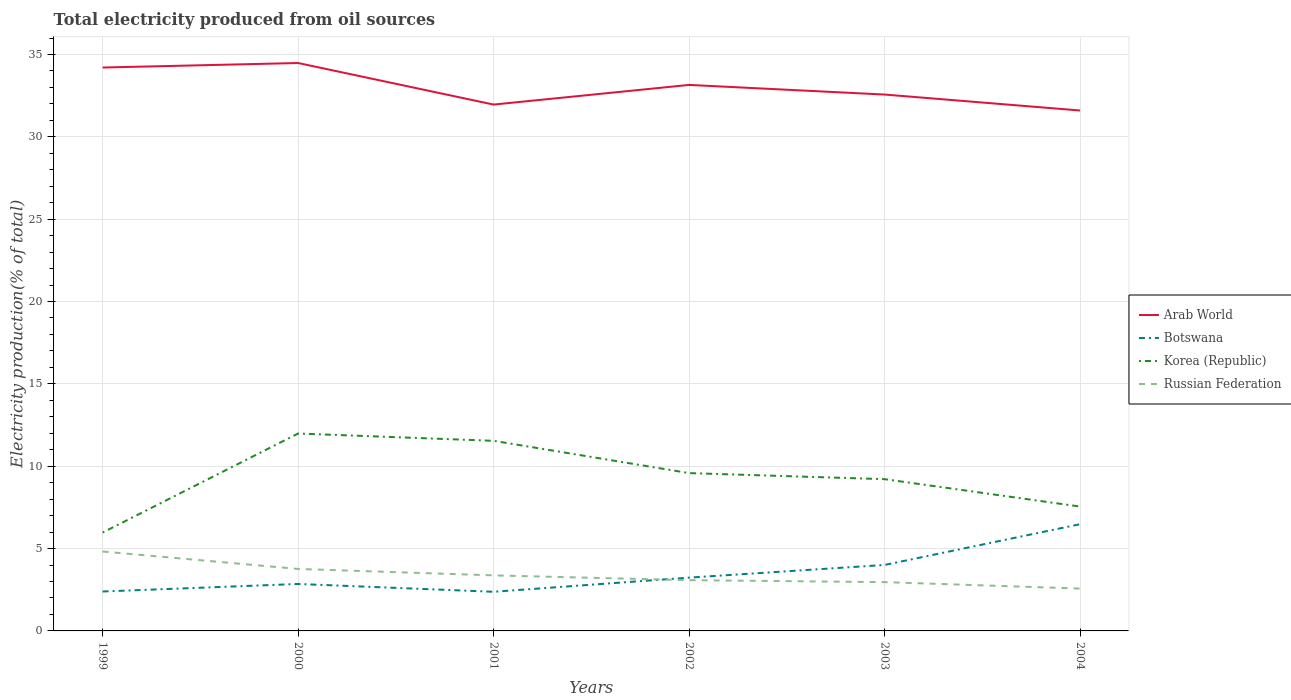Across all years, what is the maximum total electricity produced in Arab World?
Give a very brief answer. 31.6. What is the total total electricity produced in Botswana in the graph?
Provide a short and direct response. -4.1. What is the difference between the highest and the second highest total electricity produced in Botswana?
Your response must be concise. 4.1. What is the difference between two consecutive major ticks on the Y-axis?
Ensure brevity in your answer.  5. Does the graph contain any zero values?
Your answer should be very brief. No. Does the graph contain grids?
Your response must be concise. Yes. How many legend labels are there?
Give a very brief answer. 4. What is the title of the graph?
Your response must be concise. Total electricity produced from oil sources. Does "Spain" appear as one of the legend labels in the graph?
Provide a succinct answer. No. What is the label or title of the X-axis?
Offer a very short reply. Years. What is the label or title of the Y-axis?
Ensure brevity in your answer.  Electricity production(% of total). What is the Electricity production(% of total) of Arab World in 1999?
Provide a short and direct response. 34.21. What is the Electricity production(% of total) in Botswana in 1999?
Provide a short and direct response. 2.39. What is the Electricity production(% of total) in Korea (Republic) in 1999?
Provide a succinct answer. 5.97. What is the Electricity production(% of total) in Russian Federation in 1999?
Provide a short and direct response. 4.82. What is the Electricity production(% of total) of Arab World in 2000?
Your answer should be compact. 34.48. What is the Electricity production(% of total) in Botswana in 2000?
Your answer should be very brief. 2.85. What is the Electricity production(% of total) of Korea (Republic) in 2000?
Your response must be concise. 11.99. What is the Electricity production(% of total) in Russian Federation in 2000?
Give a very brief answer. 3.76. What is the Electricity production(% of total) in Arab World in 2001?
Provide a succinct answer. 31.96. What is the Electricity production(% of total) in Botswana in 2001?
Make the answer very short. 2.38. What is the Electricity production(% of total) in Korea (Republic) in 2001?
Your response must be concise. 11.54. What is the Electricity production(% of total) of Russian Federation in 2001?
Offer a very short reply. 3.37. What is the Electricity production(% of total) of Arab World in 2002?
Your answer should be very brief. 33.15. What is the Electricity production(% of total) of Botswana in 2002?
Your answer should be very brief. 3.24. What is the Electricity production(% of total) of Korea (Republic) in 2002?
Ensure brevity in your answer.  9.58. What is the Electricity production(% of total) of Russian Federation in 2002?
Your answer should be very brief. 3.08. What is the Electricity production(% of total) in Arab World in 2003?
Offer a terse response. 32.57. What is the Electricity production(% of total) in Botswana in 2003?
Make the answer very short. 4.01. What is the Electricity production(% of total) in Korea (Republic) in 2003?
Give a very brief answer. 9.21. What is the Electricity production(% of total) of Russian Federation in 2003?
Your answer should be very brief. 2.96. What is the Electricity production(% of total) in Arab World in 2004?
Make the answer very short. 31.6. What is the Electricity production(% of total) of Botswana in 2004?
Keep it short and to the point. 6.48. What is the Electricity production(% of total) in Korea (Republic) in 2004?
Provide a succinct answer. 7.55. What is the Electricity production(% of total) in Russian Federation in 2004?
Offer a terse response. 2.57. Across all years, what is the maximum Electricity production(% of total) in Arab World?
Make the answer very short. 34.48. Across all years, what is the maximum Electricity production(% of total) in Botswana?
Make the answer very short. 6.48. Across all years, what is the maximum Electricity production(% of total) of Korea (Republic)?
Your answer should be very brief. 11.99. Across all years, what is the maximum Electricity production(% of total) of Russian Federation?
Ensure brevity in your answer.  4.82. Across all years, what is the minimum Electricity production(% of total) of Arab World?
Offer a very short reply. 31.6. Across all years, what is the minimum Electricity production(% of total) in Botswana?
Your response must be concise. 2.38. Across all years, what is the minimum Electricity production(% of total) in Korea (Republic)?
Provide a succinct answer. 5.97. Across all years, what is the minimum Electricity production(% of total) in Russian Federation?
Give a very brief answer. 2.57. What is the total Electricity production(% of total) of Arab World in the graph?
Offer a terse response. 197.97. What is the total Electricity production(% of total) in Botswana in the graph?
Your answer should be compact. 21.34. What is the total Electricity production(% of total) of Korea (Republic) in the graph?
Provide a short and direct response. 55.85. What is the total Electricity production(% of total) in Russian Federation in the graph?
Ensure brevity in your answer.  20.57. What is the difference between the Electricity production(% of total) in Arab World in 1999 and that in 2000?
Ensure brevity in your answer.  -0.27. What is the difference between the Electricity production(% of total) in Botswana in 1999 and that in 2000?
Your answer should be very brief. -0.46. What is the difference between the Electricity production(% of total) of Korea (Republic) in 1999 and that in 2000?
Your answer should be compact. -6.01. What is the difference between the Electricity production(% of total) of Russian Federation in 1999 and that in 2000?
Make the answer very short. 1.06. What is the difference between the Electricity production(% of total) of Arab World in 1999 and that in 2001?
Give a very brief answer. 2.25. What is the difference between the Electricity production(% of total) of Botswana in 1999 and that in 2001?
Give a very brief answer. 0.02. What is the difference between the Electricity production(% of total) in Korea (Republic) in 1999 and that in 2001?
Make the answer very short. -5.57. What is the difference between the Electricity production(% of total) in Russian Federation in 1999 and that in 2001?
Keep it short and to the point. 1.45. What is the difference between the Electricity production(% of total) of Arab World in 1999 and that in 2002?
Ensure brevity in your answer.  1.06. What is the difference between the Electricity production(% of total) of Botswana in 1999 and that in 2002?
Offer a very short reply. -0.84. What is the difference between the Electricity production(% of total) of Korea (Republic) in 1999 and that in 2002?
Ensure brevity in your answer.  -3.61. What is the difference between the Electricity production(% of total) in Russian Federation in 1999 and that in 2002?
Make the answer very short. 1.74. What is the difference between the Electricity production(% of total) of Arab World in 1999 and that in 2003?
Provide a succinct answer. 1.64. What is the difference between the Electricity production(% of total) of Botswana in 1999 and that in 2003?
Provide a short and direct response. -1.61. What is the difference between the Electricity production(% of total) of Korea (Republic) in 1999 and that in 2003?
Offer a very short reply. -3.24. What is the difference between the Electricity production(% of total) of Russian Federation in 1999 and that in 2003?
Your answer should be compact. 1.86. What is the difference between the Electricity production(% of total) of Arab World in 1999 and that in 2004?
Offer a terse response. 2.61. What is the difference between the Electricity production(% of total) of Botswana in 1999 and that in 2004?
Offer a terse response. -4.09. What is the difference between the Electricity production(% of total) in Korea (Republic) in 1999 and that in 2004?
Your answer should be very brief. -1.58. What is the difference between the Electricity production(% of total) in Russian Federation in 1999 and that in 2004?
Ensure brevity in your answer.  2.25. What is the difference between the Electricity production(% of total) of Arab World in 2000 and that in 2001?
Make the answer very short. 2.52. What is the difference between the Electricity production(% of total) of Botswana in 2000 and that in 2001?
Your answer should be very brief. 0.47. What is the difference between the Electricity production(% of total) of Korea (Republic) in 2000 and that in 2001?
Provide a succinct answer. 0.44. What is the difference between the Electricity production(% of total) of Russian Federation in 2000 and that in 2001?
Offer a very short reply. 0.39. What is the difference between the Electricity production(% of total) of Arab World in 2000 and that in 2002?
Give a very brief answer. 1.33. What is the difference between the Electricity production(% of total) of Botswana in 2000 and that in 2002?
Ensure brevity in your answer.  -0.39. What is the difference between the Electricity production(% of total) in Korea (Republic) in 2000 and that in 2002?
Provide a short and direct response. 2.4. What is the difference between the Electricity production(% of total) of Russian Federation in 2000 and that in 2002?
Keep it short and to the point. 0.68. What is the difference between the Electricity production(% of total) of Arab World in 2000 and that in 2003?
Ensure brevity in your answer.  1.91. What is the difference between the Electricity production(% of total) of Botswana in 2000 and that in 2003?
Offer a very short reply. -1.15. What is the difference between the Electricity production(% of total) in Korea (Republic) in 2000 and that in 2003?
Give a very brief answer. 2.77. What is the difference between the Electricity production(% of total) in Russian Federation in 2000 and that in 2003?
Provide a short and direct response. 0.8. What is the difference between the Electricity production(% of total) in Arab World in 2000 and that in 2004?
Ensure brevity in your answer.  2.88. What is the difference between the Electricity production(% of total) of Botswana in 2000 and that in 2004?
Offer a terse response. -3.63. What is the difference between the Electricity production(% of total) in Korea (Republic) in 2000 and that in 2004?
Give a very brief answer. 4.44. What is the difference between the Electricity production(% of total) in Russian Federation in 2000 and that in 2004?
Make the answer very short. 1.19. What is the difference between the Electricity production(% of total) in Arab World in 2001 and that in 2002?
Give a very brief answer. -1.19. What is the difference between the Electricity production(% of total) in Botswana in 2001 and that in 2002?
Provide a succinct answer. -0.86. What is the difference between the Electricity production(% of total) of Korea (Republic) in 2001 and that in 2002?
Keep it short and to the point. 1.96. What is the difference between the Electricity production(% of total) in Russian Federation in 2001 and that in 2002?
Offer a very short reply. 0.29. What is the difference between the Electricity production(% of total) of Arab World in 2001 and that in 2003?
Make the answer very short. -0.61. What is the difference between the Electricity production(% of total) in Botswana in 2001 and that in 2003?
Keep it short and to the point. -1.63. What is the difference between the Electricity production(% of total) of Korea (Republic) in 2001 and that in 2003?
Your answer should be compact. 2.33. What is the difference between the Electricity production(% of total) of Russian Federation in 2001 and that in 2003?
Offer a very short reply. 0.41. What is the difference between the Electricity production(% of total) of Arab World in 2001 and that in 2004?
Your answer should be very brief. 0.36. What is the difference between the Electricity production(% of total) of Botswana in 2001 and that in 2004?
Ensure brevity in your answer.  -4.1. What is the difference between the Electricity production(% of total) in Korea (Republic) in 2001 and that in 2004?
Give a very brief answer. 3.99. What is the difference between the Electricity production(% of total) in Russian Federation in 2001 and that in 2004?
Offer a very short reply. 0.8. What is the difference between the Electricity production(% of total) in Arab World in 2002 and that in 2003?
Give a very brief answer. 0.58. What is the difference between the Electricity production(% of total) of Botswana in 2002 and that in 2003?
Your response must be concise. -0.77. What is the difference between the Electricity production(% of total) in Korea (Republic) in 2002 and that in 2003?
Give a very brief answer. 0.37. What is the difference between the Electricity production(% of total) in Russian Federation in 2002 and that in 2003?
Offer a very short reply. 0.12. What is the difference between the Electricity production(% of total) of Arab World in 2002 and that in 2004?
Your answer should be very brief. 1.55. What is the difference between the Electricity production(% of total) of Botswana in 2002 and that in 2004?
Provide a short and direct response. -3.24. What is the difference between the Electricity production(% of total) of Korea (Republic) in 2002 and that in 2004?
Make the answer very short. 2.03. What is the difference between the Electricity production(% of total) of Russian Federation in 2002 and that in 2004?
Provide a short and direct response. 0.51. What is the difference between the Electricity production(% of total) in Arab World in 2003 and that in 2004?
Give a very brief answer. 0.97. What is the difference between the Electricity production(% of total) in Botswana in 2003 and that in 2004?
Provide a succinct answer. -2.47. What is the difference between the Electricity production(% of total) of Korea (Republic) in 2003 and that in 2004?
Your answer should be very brief. 1.66. What is the difference between the Electricity production(% of total) in Russian Federation in 2003 and that in 2004?
Provide a short and direct response. 0.39. What is the difference between the Electricity production(% of total) in Arab World in 1999 and the Electricity production(% of total) in Botswana in 2000?
Your answer should be very brief. 31.36. What is the difference between the Electricity production(% of total) of Arab World in 1999 and the Electricity production(% of total) of Korea (Republic) in 2000?
Ensure brevity in your answer.  22.22. What is the difference between the Electricity production(% of total) in Arab World in 1999 and the Electricity production(% of total) in Russian Federation in 2000?
Give a very brief answer. 30.44. What is the difference between the Electricity production(% of total) in Botswana in 1999 and the Electricity production(% of total) in Korea (Republic) in 2000?
Make the answer very short. -9.59. What is the difference between the Electricity production(% of total) of Botswana in 1999 and the Electricity production(% of total) of Russian Federation in 2000?
Ensure brevity in your answer.  -1.37. What is the difference between the Electricity production(% of total) of Korea (Republic) in 1999 and the Electricity production(% of total) of Russian Federation in 2000?
Ensure brevity in your answer.  2.21. What is the difference between the Electricity production(% of total) in Arab World in 1999 and the Electricity production(% of total) in Botswana in 2001?
Provide a succinct answer. 31.83. What is the difference between the Electricity production(% of total) of Arab World in 1999 and the Electricity production(% of total) of Korea (Republic) in 2001?
Provide a succinct answer. 22.67. What is the difference between the Electricity production(% of total) of Arab World in 1999 and the Electricity production(% of total) of Russian Federation in 2001?
Provide a succinct answer. 30.84. What is the difference between the Electricity production(% of total) in Botswana in 1999 and the Electricity production(% of total) in Korea (Republic) in 2001?
Ensure brevity in your answer.  -9.15. What is the difference between the Electricity production(% of total) of Botswana in 1999 and the Electricity production(% of total) of Russian Federation in 2001?
Your answer should be very brief. -0.98. What is the difference between the Electricity production(% of total) of Korea (Republic) in 1999 and the Electricity production(% of total) of Russian Federation in 2001?
Provide a short and direct response. 2.6. What is the difference between the Electricity production(% of total) of Arab World in 1999 and the Electricity production(% of total) of Botswana in 2002?
Make the answer very short. 30.97. What is the difference between the Electricity production(% of total) of Arab World in 1999 and the Electricity production(% of total) of Korea (Republic) in 2002?
Keep it short and to the point. 24.63. What is the difference between the Electricity production(% of total) in Arab World in 1999 and the Electricity production(% of total) in Russian Federation in 2002?
Ensure brevity in your answer.  31.13. What is the difference between the Electricity production(% of total) in Botswana in 1999 and the Electricity production(% of total) in Korea (Republic) in 2002?
Give a very brief answer. -7.19. What is the difference between the Electricity production(% of total) in Botswana in 1999 and the Electricity production(% of total) in Russian Federation in 2002?
Your response must be concise. -0.69. What is the difference between the Electricity production(% of total) in Korea (Republic) in 1999 and the Electricity production(% of total) in Russian Federation in 2002?
Keep it short and to the point. 2.89. What is the difference between the Electricity production(% of total) in Arab World in 1999 and the Electricity production(% of total) in Botswana in 2003?
Your answer should be compact. 30.2. What is the difference between the Electricity production(% of total) in Arab World in 1999 and the Electricity production(% of total) in Korea (Republic) in 2003?
Offer a very short reply. 24.99. What is the difference between the Electricity production(% of total) in Arab World in 1999 and the Electricity production(% of total) in Russian Federation in 2003?
Your response must be concise. 31.24. What is the difference between the Electricity production(% of total) of Botswana in 1999 and the Electricity production(% of total) of Korea (Republic) in 2003?
Your answer should be very brief. -6.82. What is the difference between the Electricity production(% of total) of Botswana in 1999 and the Electricity production(% of total) of Russian Federation in 2003?
Keep it short and to the point. -0.57. What is the difference between the Electricity production(% of total) in Korea (Republic) in 1999 and the Electricity production(% of total) in Russian Federation in 2003?
Your answer should be compact. 3.01. What is the difference between the Electricity production(% of total) in Arab World in 1999 and the Electricity production(% of total) in Botswana in 2004?
Your response must be concise. 27.73. What is the difference between the Electricity production(% of total) in Arab World in 1999 and the Electricity production(% of total) in Korea (Republic) in 2004?
Your response must be concise. 26.66. What is the difference between the Electricity production(% of total) in Arab World in 1999 and the Electricity production(% of total) in Russian Federation in 2004?
Provide a short and direct response. 31.64. What is the difference between the Electricity production(% of total) in Botswana in 1999 and the Electricity production(% of total) in Korea (Republic) in 2004?
Your answer should be compact. -5.16. What is the difference between the Electricity production(% of total) in Botswana in 1999 and the Electricity production(% of total) in Russian Federation in 2004?
Ensure brevity in your answer.  -0.18. What is the difference between the Electricity production(% of total) in Korea (Republic) in 1999 and the Electricity production(% of total) in Russian Federation in 2004?
Provide a succinct answer. 3.4. What is the difference between the Electricity production(% of total) of Arab World in 2000 and the Electricity production(% of total) of Botswana in 2001?
Ensure brevity in your answer.  32.11. What is the difference between the Electricity production(% of total) in Arab World in 2000 and the Electricity production(% of total) in Korea (Republic) in 2001?
Keep it short and to the point. 22.94. What is the difference between the Electricity production(% of total) of Arab World in 2000 and the Electricity production(% of total) of Russian Federation in 2001?
Offer a very short reply. 31.11. What is the difference between the Electricity production(% of total) of Botswana in 2000 and the Electricity production(% of total) of Korea (Republic) in 2001?
Keep it short and to the point. -8.69. What is the difference between the Electricity production(% of total) of Botswana in 2000 and the Electricity production(% of total) of Russian Federation in 2001?
Your answer should be very brief. -0.52. What is the difference between the Electricity production(% of total) in Korea (Republic) in 2000 and the Electricity production(% of total) in Russian Federation in 2001?
Your response must be concise. 8.61. What is the difference between the Electricity production(% of total) of Arab World in 2000 and the Electricity production(% of total) of Botswana in 2002?
Keep it short and to the point. 31.25. What is the difference between the Electricity production(% of total) of Arab World in 2000 and the Electricity production(% of total) of Korea (Republic) in 2002?
Your answer should be compact. 24.9. What is the difference between the Electricity production(% of total) in Arab World in 2000 and the Electricity production(% of total) in Russian Federation in 2002?
Offer a very short reply. 31.4. What is the difference between the Electricity production(% of total) in Botswana in 2000 and the Electricity production(% of total) in Korea (Republic) in 2002?
Provide a short and direct response. -6.73. What is the difference between the Electricity production(% of total) in Botswana in 2000 and the Electricity production(% of total) in Russian Federation in 2002?
Your answer should be very brief. -0.23. What is the difference between the Electricity production(% of total) in Korea (Republic) in 2000 and the Electricity production(% of total) in Russian Federation in 2002?
Your answer should be compact. 8.9. What is the difference between the Electricity production(% of total) in Arab World in 2000 and the Electricity production(% of total) in Botswana in 2003?
Keep it short and to the point. 30.48. What is the difference between the Electricity production(% of total) of Arab World in 2000 and the Electricity production(% of total) of Korea (Republic) in 2003?
Your answer should be very brief. 25.27. What is the difference between the Electricity production(% of total) of Arab World in 2000 and the Electricity production(% of total) of Russian Federation in 2003?
Offer a very short reply. 31.52. What is the difference between the Electricity production(% of total) in Botswana in 2000 and the Electricity production(% of total) in Korea (Republic) in 2003?
Ensure brevity in your answer.  -6.36. What is the difference between the Electricity production(% of total) in Botswana in 2000 and the Electricity production(% of total) in Russian Federation in 2003?
Offer a terse response. -0.11. What is the difference between the Electricity production(% of total) of Korea (Republic) in 2000 and the Electricity production(% of total) of Russian Federation in 2003?
Provide a succinct answer. 9.02. What is the difference between the Electricity production(% of total) of Arab World in 2000 and the Electricity production(% of total) of Botswana in 2004?
Your response must be concise. 28. What is the difference between the Electricity production(% of total) in Arab World in 2000 and the Electricity production(% of total) in Korea (Republic) in 2004?
Your response must be concise. 26.93. What is the difference between the Electricity production(% of total) of Arab World in 2000 and the Electricity production(% of total) of Russian Federation in 2004?
Keep it short and to the point. 31.91. What is the difference between the Electricity production(% of total) of Botswana in 2000 and the Electricity production(% of total) of Korea (Republic) in 2004?
Keep it short and to the point. -4.7. What is the difference between the Electricity production(% of total) of Botswana in 2000 and the Electricity production(% of total) of Russian Federation in 2004?
Make the answer very short. 0.28. What is the difference between the Electricity production(% of total) in Korea (Republic) in 2000 and the Electricity production(% of total) in Russian Federation in 2004?
Provide a succinct answer. 9.41. What is the difference between the Electricity production(% of total) in Arab World in 2001 and the Electricity production(% of total) in Botswana in 2002?
Provide a short and direct response. 28.72. What is the difference between the Electricity production(% of total) of Arab World in 2001 and the Electricity production(% of total) of Korea (Republic) in 2002?
Ensure brevity in your answer.  22.38. What is the difference between the Electricity production(% of total) of Arab World in 2001 and the Electricity production(% of total) of Russian Federation in 2002?
Your answer should be very brief. 28.88. What is the difference between the Electricity production(% of total) in Botswana in 2001 and the Electricity production(% of total) in Korea (Republic) in 2002?
Offer a very short reply. -7.21. What is the difference between the Electricity production(% of total) in Botswana in 2001 and the Electricity production(% of total) in Russian Federation in 2002?
Ensure brevity in your answer.  -0.71. What is the difference between the Electricity production(% of total) of Korea (Republic) in 2001 and the Electricity production(% of total) of Russian Federation in 2002?
Provide a succinct answer. 8.46. What is the difference between the Electricity production(% of total) in Arab World in 2001 and the Electricity production(% of total) in Botswana in 2003?
Make the answer very short. 27.95. What is the difference between the Electricity production(% of total) in Arab World in 2001 and the Electricity production(% of total) in Korea (Republic) in 2003?
Provide a succinct answer. 22.74. What is the difference between the Electricity production(% of total) of Arab World in 2001 and the Electricity production(% of total) of Russian Federation in 2003?
Give a very brief answer. 29. What is the difference between the Electricity production(% of total) of Botswana in 2001 and the Electricity production(% of total) of Korea (Republic) in 2003?
Provide a succinct answer. -6.84. What is the difference between the Electricity production(% of total) in Botswana in 2001 and the Electricity production(% of total) in Russian Federation in 2003?
Your answer should be very brief. -0.59. What is the difference between the Electricity production(% of total) of Korea (Republic) in 2001 and the Electricity production(% of total) of Russian Federation in 2003?
Your answer should be compact. 8.58. What is the difference between the Electricity production(% of total) of Arab World in 2001 and the Electricity production(% of total) of Botswana in 2004?
Give a very brief answer. 25.48. What is the difference between the Electricity production(% of total) of Arab World in 2001 and the Electricity production(% of total) of Korea (Republic) in 2004?
Keep it short and to the point. 24.41. What is the difference between the Electricity production(% of total) of Arab World in 2001 and the Electricity production(% of total) of Russian Federation in 2004?
Make the answer very short. 29.39. What is the difference between the Electricity production(% of total) in Botswana in 2001 and the Electricity production(% of total) in Korea (Republic) in 2004?
Provide a succinct answer. -5.17. What is the difference between the Electricity production(% of total) in Botswana in 2001 and the Electricity production(% of total) in Russian Federation in 2004?
Keep it short and to the point. -0.19. What is the difference between the Electricity production(% of total) of Korea (Republic) in 2001 and the Electricity production(% of total) of Russian Federation in 2004?
Ensure brevity in your answer.  8.97. What is the difference between the Electricity production(% of total) of Arab World in 2002 and the Electricity production(% of total) of Botswana in 2003?
Offer a very short reply. 29.15. What is the difference between the Electricity production(% of total) of Arab World in 2002 and the Electricity production(% of total) of Korea (Republic) in 2003?
Keep it short and to the point. 23.94. What is the difference between the Electricity production(% of total) of Arab World in 2002 and the Electricity production(% of total) of Russian Federation in 2003?
Offer a very short reply. 30.19. What is the difference between the Electricity production(% of total) in Botswana in 2002 and the Electricity production(% of total) in Korea (Republic) in 2003?
Ensure brevity in your answer.  -5.98. What is the difference between the Electricity production(% of total) of Botswana in 2002 and the Electricity production(% of total) of Russian Federation in 2003?
Provide a succinct answer. 0.27. What is the difference between the Electricity production(% of total) of Korea (Republic) in 2002 and the Electricity production(% of total) of Russian Federation in 2003?
Offer a terse response. 6.62. What is the difference between the Electricity production(% of total) of Arab World in 2002 and the Electricity production(% of total) of Botswana in 2004?
Your response must be concise. 26.67. What is the difference between the Electricity production(% of total) in Arab World in 2002 and the Electricity production(% of total) in Korea (Republic) in 2004?
Make the answer very short. 25.6. What is the difference between the Electricity production(% of total) in Arab World in 2002 and the Electricity production(% of total) in Russian Federation in 2004?
Your response must be concise. 30.58. What is the difference between the Electricity production(% of total) in Botswana in 2002 and the Electricity production(% of total) in Korea (Republic) in 2004?
Make the answer very short. -4.31. What is the difference between the Electricity production(% of total) of Botswana in 2002 and the Electricity production(% of total) of Russian Federation in 2004?
Offer a terse response. 0.67. What is the difference between the Electricity production(% of total) in Korea (Republic) in 2002 and the Electricity production(% of total) in Russian Federation in 2004?
Ensure brevity in your answer.  7.01. What is the difference between the Electricity production(% of total) in Arab World in 2003 and the Electricity production(% of total) in Botswana in 2004?
Give a very brief answer. 26.09. What is the difference between the Electricity production(% of total) in Arab World in 2003 and the Electricity production(% of total) in Korea (Republic) in 2004?
Your response must be concise. 25.02. What is the difference between the Electricity production(% of total) of Arab World in 2003 and the Electricity production(% of total) of Russian Federation in 2004?
Your answer should be very brief. 30. What is the difference between the Electricity production(% of total) of Botswana in 2003 and the Electricity production(% of total) of Korea (Republic) in 2004?
Your answer should be very brief. -3.54. What is the difference between the Electricity production(% of total) of Botswana in 2003 and the Electricity production(% of total) of Russian Federation in 2004?
Your answer should be compact. 1.43. What is the difference between the Electricity production(% of total) of Korea (Republic) in 2003 and the Electricity production(% of total) of Russian Federation in 2004?
Your answer should be very brief. 6.64. What is the average Electricity production(% of total) of Arab World per year?
Keep it short and to the point. 32.99. What is the average Electricity production(% of total) in Botswana per year?
Give a very brief answer. 3.56. What is the average Electricity production(% of total) in Korea (Republic) per year?
Provide a short and direct response. 9.31. What is the average Electricity production(% of total) of Russian Federation per year?
Give a very brief answer. 3.43. In the year 1999, what is the difference between the Electricity production(% of total) in Arab World and Electricity production(% of total) in Botswana?
Offer a terse response. 31.81. In the year 1999, what is the difference between the Electricity production(% of total) in Arab World and Electricity production(% of total) in Korea (Republic)?
Offer a terse response. 28.24. In the year 1999, what is the difference between the Electricity production(% of total) of Arab World and Electricity production(% of total) of Russian Federation?
Provide a succinct answer. 29.39. In the year 1999, what is the difference between the Electricity production(% of total) of Botswana and Electricity production(% of total) of Korea (Republic)?
Your answer should be compact. -3.58. In the year 1999, what is the difference between the Electricity production(% of total) of Botswana and Electricity production(% of total) of Russian Federation?
Provide a short and direct response. -2.43. In the year 1999, what is the difference between the Electricity production(% of total) in Korea (Republic) and Electricity production(% of total) in Russian Federation?
Make the answer very short. 1.15. In the year 2000, what is the difference between the Electricity production(% of total) of Arab World and Electricity production(% of total) of Botswana?
Provide a succinct answer. 31.63. In the year 2000, what is the difference between the Electricity production(% of total) in Arab World and Electricity production(% of total) in Korea (Republic)?
Provide a short and direct response. 22.5. In the year 2000, what is the difference between the Electricity production(% of total) of Arab World and Electricity production(% of total) of Russian Federation?
Your response must be concise. 30.72. In the year 2000, what is the difference between the Electricity production(% of total) of Botswana and Electricity production(% of total) of Korea (Republic)?
Your response must be concise. -9.13. In the year 2000, what is the difference between the Electricity production(% of total) in Botswana and Electricity production(% of total) in Russian Federation?
Provide a short and direct response. -0.91. In the year 2000, what is the difference between the Electricity production(% of total) in Korea (Republic) and Electricity production(% of total) in Russian Federation?
Provide a short and direct response. 8.22. In the year 2001, what is the difference between the Electricity production(% of total) of Arab World and Electricity production(% of total) of Botswana?
Your response must be concise. 29.58. In the year 2001, what is the difference between the Electricity production(% of total) of Arab World and Electricity production(% of total) of Korea (Republic)?
Provide a short and direct response. 20.42. In the year 2001, what is the difference between the Electricity production(% of total) in Arab World and Electricity production(% of total) in Russian Federation?
Your answer should be compact. 28.59. In the year 2001, what is the difference between the Electricity production(% of total) of Botswana and Electricity production(% of total) of Korea (Republic)?
Your response must be concise. -9.17. In the year 2001, what is the difference between the Electricity production(% of total) of Botswana and Electricity production(% of total) of Russian Federation?
Make the answer very short. -1. In the year 2001, what is the difference between the Electricity production(% of total) in Korea (Republic) and Electricity production(% of total) in Russian Federation?
Provide a short and direct response. 8.17. In the year 2002, what is the difference between the Electricity production(% of total) in Arab World and Electricity production(% of total) in Botswana?
Your answer should be compact. 29.92. In the year 2002, what is the difference between the Electricity production(% of total) in Arab World and Electricity production(% of total) in Korea (Republic)?
Your answer should be very brief. 23.57. In the year 2002, what is the difference between the Electricity production(% of total) in Arab World and Electricity production(% of total) in Russian Federation?
Give a very brief answer. 30.07. In the year 2002, what is the difference between the Electricity production(% of total) of Botswana and Electricity production(% of total) of Korea (Republic)?
Provide a short and direct response. -6.35. In the year 2002, what is the difference between the Electricity production(% of total) in Botswana and Electricity production(% of total) in Russian Federation?
Keep it short and to the point. 0.16. In the year 2002, what is the difference between the Electricity production(% of total) in Korea (Republic) and Electricity production(% of total) in Russian Federation?
Offer a very short reply. 6.5. In the year 2003, what is the difference between the Electricity production(% of total) of Arab World and Electricity production(% of total) of Botswana?
Your answer should be compact. 28.56. In the year 2003, what is the difference between the Electricity production(% of total) of Arab World and Electricity production(% of total) of Korea (Republic)?
Offer a terse response. 23.35. In the year 2003, what is the difference between the Electricity production(% of total) in Arab World and Electricity production(% of total) in Russian Federation?
Ensure brevity in your answer.  29.6. In the year 2003, what is the difference between the Electricity production(% of total) in Botswana and Electricity production(% of total) in Korea (Republic)?
Ensure brevity in your answer.  -5.21. In the year 2003, what is the difference between the Electricity production(% of total) of Botswana and Electricity production(% of total) of Russian Federation?
Your response must be concise. 1.04. In the year 2003, what is the difference between the Electricity production(% of total) of Korea (Republic) and Electricity production(% of total) of Russian Federation?
Offer a terse response. 6.25. In the year 2004, what is the difference between the Electricity production(% of total) in Arab World and Electricity production(% of total) in Botswana?
Provide a succinct answer. 25.12. In the year 2004, what is the difference between the Electricity production(% of total) in Arab World and Electricity production(% of total) in Korea (Republic)?
Provide a succinct answer. 24.05. In the year 2004, what is the difference between the Electricity production(% of total) of Arab World and Electricity production(% of total) of Russian Federation?
Offer a very short reply. 29.03. In the year 2004, what is the difference between the Electricity production(% of total) in Botswana and Electricity production(% of total) in Korea (Republic)?
Offer a terse response. -1.07. In the year 2004, what is the difference between the Electricity production(% of total) of Botswana and Electricity production(% of total) of Russian Federation?
Your response must be concise. 3.91. In the year 2004, what is the difference between the Electricity production(% of total) in Korea (Republic) and Electricity production(% of total) in Russian Federation?
Keep it short and to the point. 4.98. What is the ratio of the Electricity production(% of total) of Arab World in 1999 to that in 2000?
Your response must be concise. 0.99. What is the ratio of the Electricity production(% of total) in Botswana in 1999 to that in 2000?
Your answer should be compact. 0.84. What is the ratio of the Electricity production(% of total) in Korea (Republic) in 1999 to that in 2000?
Make the answer very short. 0.5. What is the ratio of the Electricity production(% of total) in Russian Federation in 1999 to that in 2000?
Give a very brief answer. 1.28. What is the ratio of the Electricity production(% of total) of Arab World in 1999 to that in 2001?
Give a very brief answer. 1.07. What is the ratio of the Electricity production(% of total) in Botswana in 1999 to that in 2001?
Provide a succinct answer. 1.01. What is the ratio of the Electricity production(% of total) of Korea (Republic) in 1999 to that in 2001?
Keep it short and to the point. 0.52. What is the ratio of the Electricity production(% of total) of Russian Federation in 1999 to that in 2001?
Give a very brief answer. 1.43. What is the ratio of the Electricity production(% of total) in Arab World in 1999 to that in 2002?
Provide a succinct answer. 1.03. What is the ratio of the Electricity production(% of total) in Botswana in 1999 to that in 2002?
Make the answer very short. 0.74. What is the ratio of the Electricity production(% of total) of Korea (Republic) in 1999 to that in 2002?
Give a very brief answer. 0.62. What is the ratio of the Electricity production(% of total) of Russian Federation in 1999 to that in 2002?
Provide a short and direct response. 1.56. What is the ratio of the Electricity production(% of total) in Arab World in 1999 to that in 2003?
Provide a short and direct response. 1.05. What is the ratio of the Electricity production(% of total) in Botswana in 1999 to that in 2003?
Your response must be concise. 0.6. What is the ratio of the Electricity production(% of total) of Korea (Republic) in 1999 to that in 2003?
Keep it short and to the point. 0.65. What is the ratio of the Electricity production(% of total) of Russian Federation in 1999 to that in 2003?
Make the answer very short. 1.63. What is the ratio of the Electricity production(% of total) in Arab World in 1999 to that in 2004?
Offer a very short reply. 1.08. What is the ratio of the Electricity production(% of total) in Botswana in 1999 to that in 2004?
Offer a terse response. 0.37. What is the ratio of the Electricity production(% of total) in Korea (Republic) in 1999 to that in 2004?
Offer a very short reply. 0.79. What is the ratio of the Electricity production(% of total) of Russian Federation in 1999 to that in 2004?
Keep it short and to the point. 1.88. What is the ratio of the Electricity production(% of total) of Arab World in 2000 to that in 2001?
Give a very brief answer. 1.08. What is the ratio of the Electricity production(% of total) in Botswana in 2000 to that in 2001?
Your response must be concise. 1.2. What is the ratio of the Electricity production(% of total) of Korea (Republic) in 2000 to that in 2001?
Give a very brief answer. 1.04. What is the ratio of the Electricity production(% of total) in Russian Federation in 2000 to that in 2001?
Your answer should be compact. 1.12. What is the ratio of the Electricity production(% of total) of Arab World in 2000 to that in 2002?
Ensure brevity in your answer.  1.04. What is the ratio of the Electricity production(% of total) in Botswana in 2000 to that in 2002?
Offer a very short reply. 0.88. What is the ratio of the Electricity production(% of total) of Korea (Republic) in 2000 to that in 2002?
Give a very brief answer. 1.25. What is the ratio of the Electricity production(% of total) in Russian Federation in 2000 to that in 2002?
Make the answer very short. 1.22. What is the ratio of the Electricity production(% of total) in Arab World in 2000 to that in 2003?
Provide a succinct answer. 1.06. What is the ratio of the Electricity production(% of total) of Botswana in 2000 to that in 2003?
Give a very brief answer. 0.71. What is the ratio of the Electricity production(% of total) of Korea (Republic) in 2000 to that in 2003?
Provide a short and direct response. 1.3. What is the ratio of the Electricity production(% of total) in Russian Federation in 2000 to that in 2003?
Your answer should be compact. 1.27. What is the ratio of the Electricity production(% of total) in Arab World in 2000 to that in 2004?
Provide a short and direct response. 1.09. What is the ratio of the Electricity production(% of total) in Botswana in 2000 to that in 2004?
Provide a succinct answer. 0.44. What is the ratio of the Electricity production(% of total) of Korea (Republic) in 2000 to that in 2004?
Ensure brevity in your answer.  1.59. What is the ratio of the Electricity production(% of total) in Russian Federation in 2000 to that in 2004?
Ensure brevity in your answer.  1.46. What is the ratio of the Electricity production(% of total) of Botswana in 2001 to that in 2002?
Provide a short and direct response. 0.73. What is the ratio of the Electricity production(% of total) in Korea (Republic) in 2001 to that in 2002?
Your response must be concise. 1.2. What is the ratio of the Electricity production(% of total) in Russian Federation in 2001 to that in 2002?
Provide a succinct answer. 1.09. What is the ratio of the Electricity production(% of total) of Arab World in 2001 to that in 2003?
Keep it short and to the point. 0.98. What is the ratio of the Electricity production(% of total) of Botswana in 2001 to that in 2003?
Your answer should be very brief. 0.59. What is the ratio of the Electricity production(% of total) in Korea (Republic) in 2001 to that in 2003?
Your answer should be compact. 1.25. What is the ratio of the Electricity production(% of total) in Russian Federation in 2001 to that in 2003?
Your response must be concise. 1.14. What is the ratio of the Electricity production(% of total) of Arab World in 2001 to that in 2004?
Ensure brevity in your answer.  1.01. What is the ratio of the Electricity production(% of total) in Botswana in 2001 to that in 2004?
Keep it short and to the point. 0.37. What is the ratio of the Electricity production(% of total) of Korea (Republic) in 2001 to that in 2004?
Your response must be concise. 1.53. What is the ratio of the Electricity production(% of total) in Russian Federation in 2001 to that in 2004?
Make the answer very short. 1.31. What is the ratio of the Electricity production(% of total) in Botswana in 2002 to that in 2003?
Offer a terse response. 0.81. What is the ratio of the Electricity production(% of total) of Korea (Republic) in 2002 to that in 2003?
Provide a short and direct response. 1.04. What is the ratio of the Electricity production(% of total) in Russian Federation in 2002 to that in 2003?
Offer a terse response. 1.04. What is the ratio of the Electricity production(% of total) in Arab World in 2002 to that in 2004?
Your answer should be compact. 1.05. What is the ratio of the Electricity production(% of total) of Botswana in 2002 to that in 2004?
Keep it short and to the point. 0.5. What is the ratio of the Electricity production(% of total) of Korea (Republic) in 2002 to that in 2004?
Provide a succinct answer. 1.27. What is the ratio of the Electricity production(% of total) of Russian Federation in 2002 to that in 2004?
Offer a very short reply. 1.2. What is the ratio of the Electricity production(% of total) of Arab World in 2003 to that in 2004?
Your answer should be very brief. 1.03. What is the ratio of the Electricity production(% of total) of Botswana in 2003 to that in 2004?
Give a very brief answer. 0.62. What is the ratio of the Electricity production(% of total) in Korea (Republic) in 2003 to that in 2004?
Offer a very short reply. 1.22. What is the ratio of the Electricity production(% of total) in Russian Federation in 2003 to that in 2004?
Provide a short and direct response. 1.15. What is the difference between the highest and the second highest Electricity production(% of total) of Arab World?
Your answer should be compact. 0.27. What is the difference between the highest and the second highest Electricity production(% of total) of Botswana?
Your answer should be compact. 2.47. What is the difference between the highest and the second highest Electricity production(% of total) in Korea (Republic)?
Offer a terse response. 0.44. What is the difference between the highest and the second highest Electricity production(% of total) in Russian Federation?
Make the answer very short. 1.06. What is the difference between the highest and the lowest Electricity production(% of total) in Arab World?
Offer a very short reply. 2.88. What is the difference between the highest and the lowest Electricity production(% of total) of Botswana?
Offer a terse response. 4.1. What is the difference between the highest and the lowest Electricity production(% of total) of Korea (Republic)?
Your answer should be very brief. 6.01. What is the difference between the highest and the lowest Electricity production(% of total) of Russian Federation?
Give a very brief answer. 2.25. 